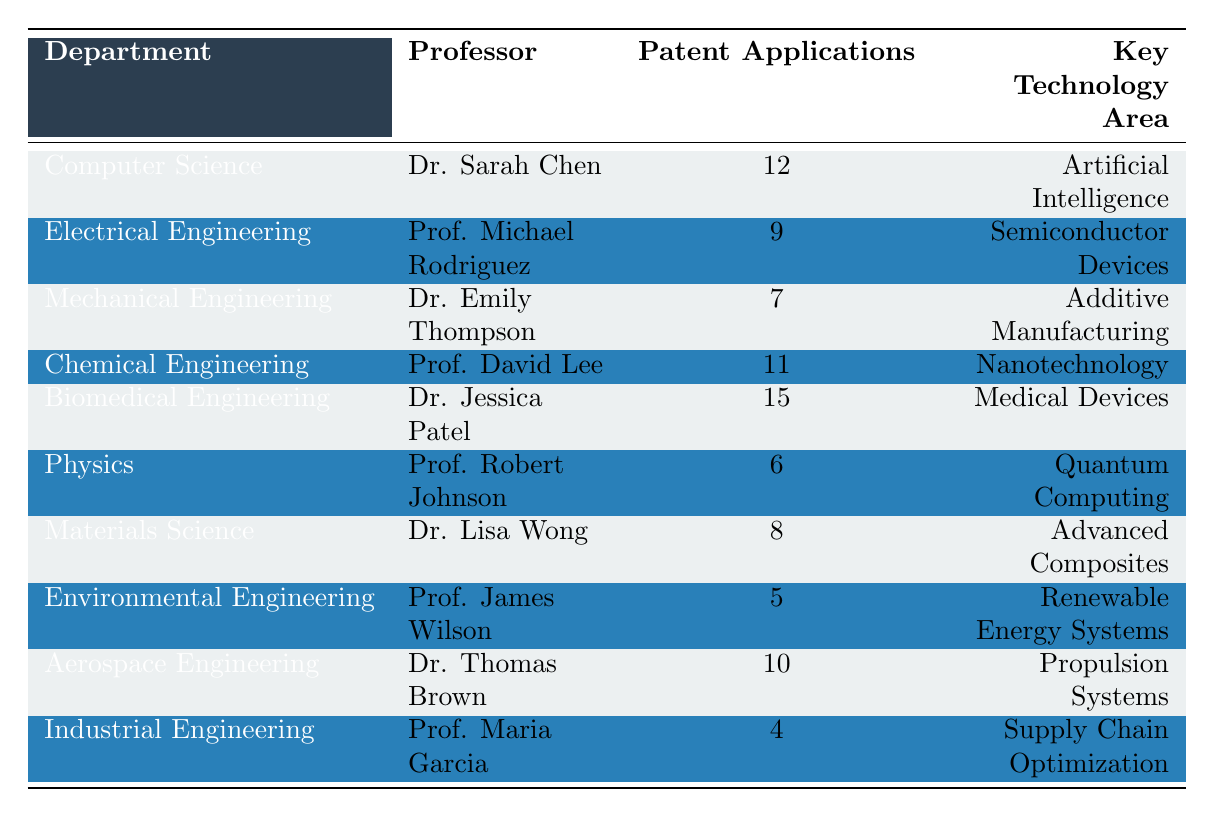What is the key technology area for Dr. Jessica Patel? According to the table, Dr. Jessica Patel's row indicates that she is working in the "Medical Devices" key technology area.
Answer: Medical Devices Which department has the highest number of patent applications filed? By examining the table, we can see that Biomedical Engineering, represented by Dr. Jessica Patel, has 15 patent applications, which is the highest among all departments.
Answer: Biomedical Engineering What is the total number of patent applications filed by the professors in the Chemical Engineering and Electrical Engineering departments? The number of patent applications for Chemical Engineering (11) and Electrical Engineering (9) can be added together: 11 + 9 = 20.
Answer: 20 Is the number of patent applications filed by Prof. Michael Rodriguez more than the average number of applications across all professors? First, we need to find the average number. The total number of applications is 12 + 9 + 7 + 11 + 15 + 6 + 8 + 5 + 10 + 4 = 87. There are 10 professors, so the average is 87 / 10 = 8.7. Prof. Michael Rodriguez filed 9 applications, which is greater than 8.7.
Answer: Yes How many professors filed more than 10 patent applications? Looking through the table, we see that Dr. Sarah Chen (12), Prof. David Lee (11), and Dr. Jessica Patel (15) filed more than 10 applications. Therefore, we count a total of 3 professors.
Answer: 3 Which professor has the least number of patent applications and what is that number? Referring to the table, Prof. Maria Garcia has filed 4 patent applications, which is the least among all the professors.
Answer: 4 If we look only at the Engineering departments, which professor among them has the second highest number of patent applications? Focusing on the Engineering departments, we have: Chemical Engineering (11), Biomedical Engineering (15), Electrical Engineering (9), Mechanical Engineering (7), Aerospace Engineering (10), and Industrial Engineering (4). The list ranked from highest to lowest is: 15, 11, 10, 9, 7, 4. Therefore, the second highest is 11, filed by Prof. David Lee from Chemical Engineering.
Answer: Prof. David Lee What is the total number of patent applications filed by professors in the departments below the average? From earlier, we calculated the average as 8.7. The professors with applications below this average are: Mechanical Engineering (7), Physics (6), Materials Science (8), Environmental Engineering (5), and Industrial Engineering (4). Summing these gives us 7 + 6 + 8 + 5 + 4 = 30.
Answer: 30 